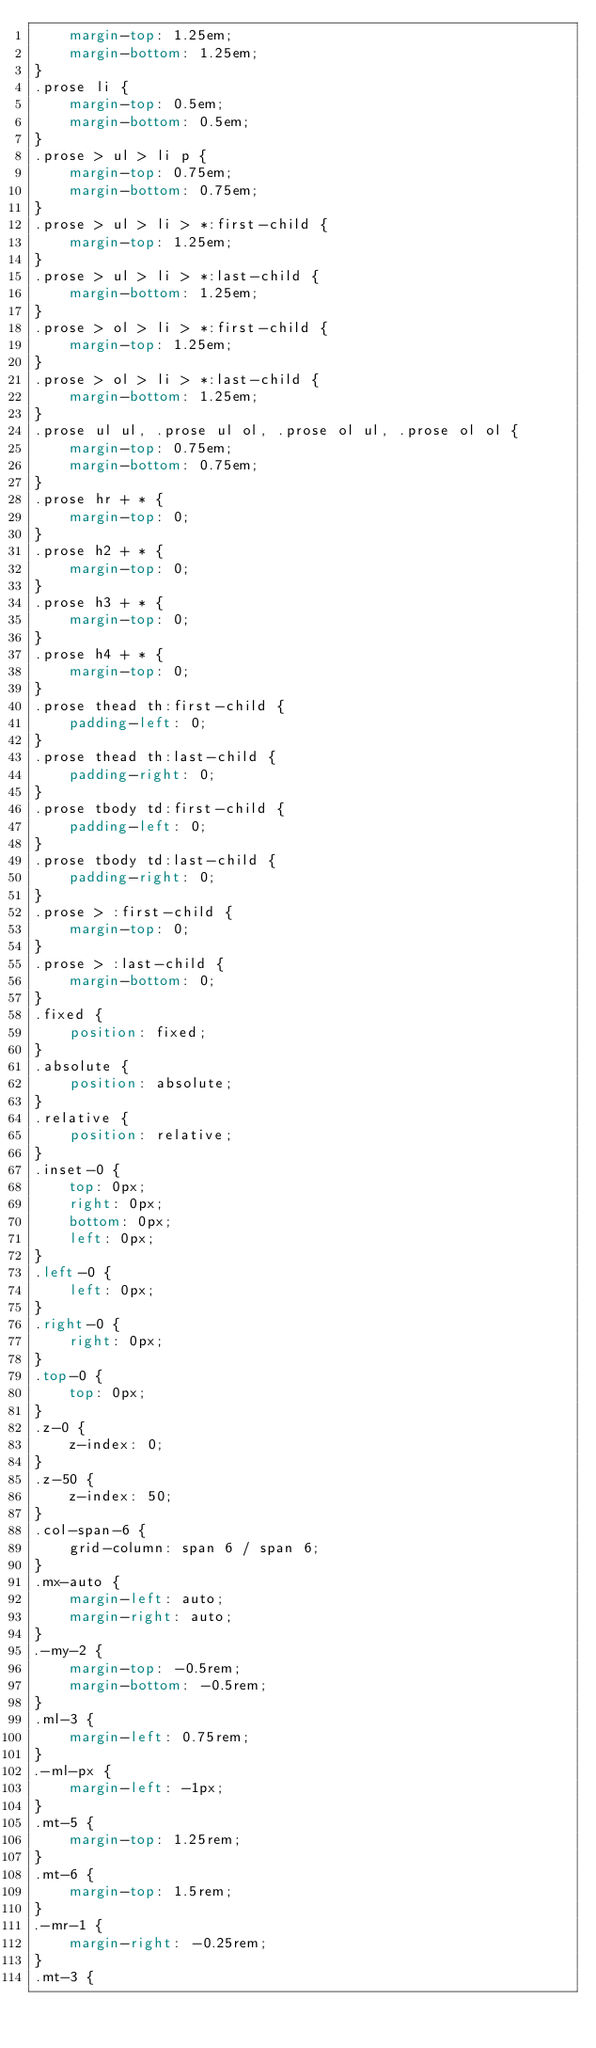Convert code to text. <code><loc_0><loc_0><loc_500><loc_500><_CSS_>	margin-top: 1.25em;
	margin-bottom: 1.25em;
}
.prose li {
	margin-top: 0.5em;
	margin-bottom: 0.5em;
}
.prose > ul > li p {
	margin-top: 0.75em;
	margin-bottom: 0.75em;
}
.prose > ul > li > *:first-child {
	margin-top: 1.25em;
}
.prose > ul > li > *:last-child {
	margin-bottom: 1.25em;
}
.prose > ol > li > *:first-child {
	margin-top: 1.25em;
}
.prose > ol > li > *:last-child {
	margin-bottom: 1.25em;
}
.prose ul ul, .prose ul ol, .prose ol ul, .prose ol ol {
	margin-top: 0.75em;
	margin-bottom: 0.75em;
}
.prose hr + * {
	margin-top: 0;
}
.prose h2 + * {
	margin-top: 0;
}
.prose h3 + * {
	margin-top: 0;
}
.prose h4 + * {
	margin-top: 0;
}
.prose thead th:first-child {
	padding-left: 0;
}
.prose thead th:last-child {
	padding-right: 0;
}
.prose tbody td:first-child {
	padding-left: 0;
}
.prose tbody td:last-child {
	padding-right: 0;
}
.prose > :first-child {
	margin-top: 0;
}
.prose > :last-child {
	margin-bottom: 0;
}
.fixed {
	position: fixed;
}
.absolute {
	position: absolute;
}
.relative {
	position: relative;
}
.inset-0 {
	top: 0px;
	right: 0px;
	bottom: 0px;
	left: 0px;
}
.left-0 {
	left: 0px;
}
.right-0 {
	right: 0px;
}
.top-0 {
	top: 0px;
}
.z-0 {
	z-index: 0;
}
.z-50 {
	z-index: 50;
}
.col-span-6 {
	grid-column: span 6 / span 6;
}
.mx-auto {
	margin-left: auto;
	margin-right: auto;
}
.-my-2 {
	margin-top: -0.5rem;
	margin-bottom: -0.5rem;
}
.ml-3 {
	margin-left: 0.75rem;
}
.-ml-px {
	margin-left: -1px;
}
.mt-5 {
	margin-top: 1.25rem;
}
.mt-6 {
	margin-top: 1.5rem;
}
.-mr-1 {
	margin-right: -0.25rem;
}
.mt-3 {</code> 